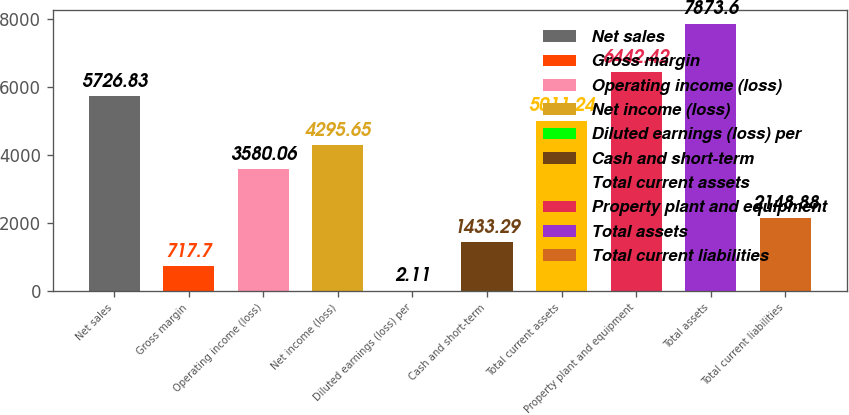<chart> <loc_0><loc_0><loc_500><loc_500><bar_chart><fcel>Net sales<fcel>Gross margin<fcel>Operating income (loss)<fcel>Net income (loss)<fcel>Diluted earnings (loss) per<fcel>Cash and short-term<fcel>Total current assets<fcel>Property plant and equipment<fcel>Total assets<fcel>Total current liabilities<nl><fcel>5726.83<fcel>717.7<fcel>3580.06<fcel>4295.65<fcel>2.11<fcel>1433.29<fcel>5011.24<fcel>6442.42<fcel>7873.6<fcel>2148.88<nl></chart> 